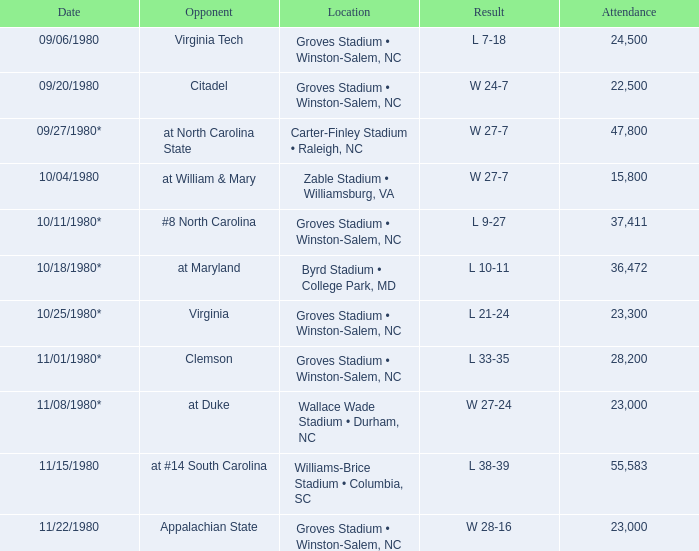How many individuals were present during the wake forest vs virginia tech game? 24500.0. 